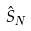<formula> <loc_0><loc_0><loc_500><loc_500>\hat { S } _ { N }</formula> 